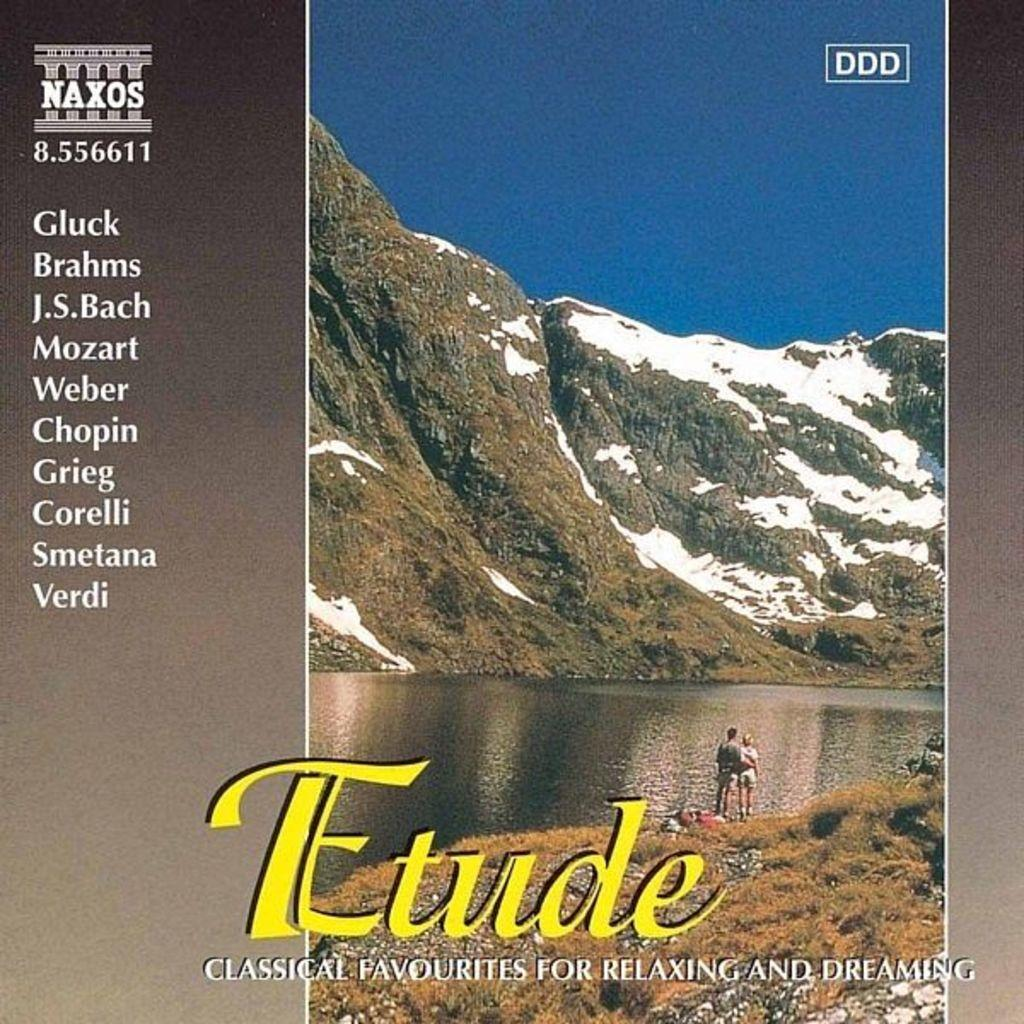Provide a one-sentence caption for the provided image. A cd called Etude that contains classical favorites for relaxing and dreaming. 